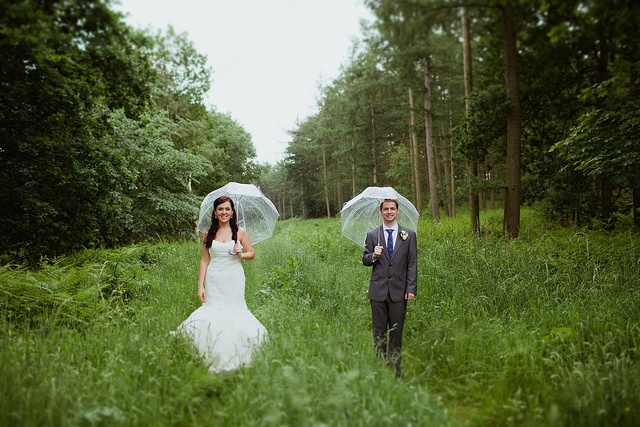Describe the objects in this image and their specific colors. I can see people in black, lightgray, darkgray, and tan tones, people in black, gray, and darkgreen tones, umbrella in black, darkgray, lightgray, gray, and lightblue tones, umbrella in black, darkgray, lightgray, olive, and gray tones, and tie in black, navy, blue, purple, and darkblue tones in this image. 